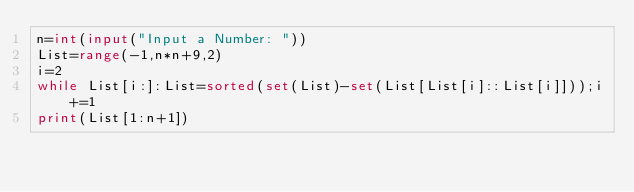Convert code to text. <code><loc_0><loc_0><loc_500><loc_500><_Python_>n=int(input("Input a Number: "))
List=range(-1,n*n+9,2)
i=2
while List[i:]:List=sorted(set(List)-set(List[List[i]::List[i]]));i+=1
print(List[1:n+1])</code> 